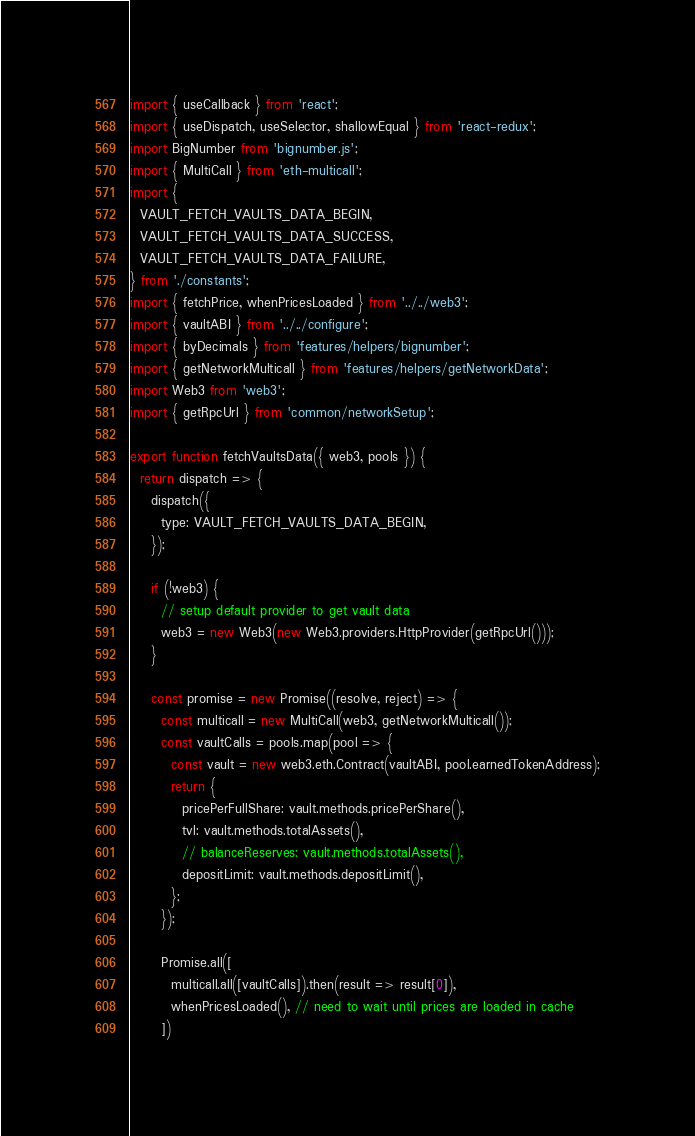Convert code to text. <code><loc_0><loc_0><loc_500><loc_500><_JavaScript_>import { useCallback } from 'react';
import { useDispatch, useSelector, shallowEqual } from 'react-redux';
import BigNumber from 'bignumber.js';
import { MultiCall } from 'eth-multicall';
import {
  VAULT_FETCH_VAULTS_DATA_BEGIN,
  VAULT_FETCH_VAULTS_DATA_SUCCESS,
  VAULT_FETCH_VAULTS_DATA_FAILURE,
} from './constants';
import { fetchPrice, whenPricesLoaded } from '../../web3';
import { vaultABI } from '../../configure';
import { byDecimals } from 'features/helpers/bignumber';
import { getNetworkMulticall } from 'features/helpers/getNetworkData';
import Web3 from 'web3';
import { getRpcUrl } from 'common/networkSetup';

export function fetchVaultsData({ web3, pools }) {
  return dispatch => {
    dispatch({
      type: VAULT_FETCH_VAULTS_DATA_BEGIN,
    });

    if (!web3) {
      // setup default provider to get vault data
      web3 = new Web3(new Web3.providers.HttpProvider(getRpcUrl()));
    }

    const promise = new Promise((resolve, reject) => {
      const multicall = new MultiCall(web3, getNetworkMulticall());
      const vaultCalls = pools.map(pool => {
        const vault = new web3.eth.Contract(vaultABI, pool.earnedTokenAddress);
        return {
          pricePerFullShare: vault.methods.pricePerShare(),
          tvl: vault.methods.totalAssets(),
          // balanceReserves: vault.methods.totalAssets(),
          depositLimit: vault.methods.depositLimit(),
        };
      });

      Promise.all([
        multicall.all([vaultCalls]).then(result => result[0]),
        whenPricesLoaded(), // need to wait until prices are loaded in cache
      ])</code> 